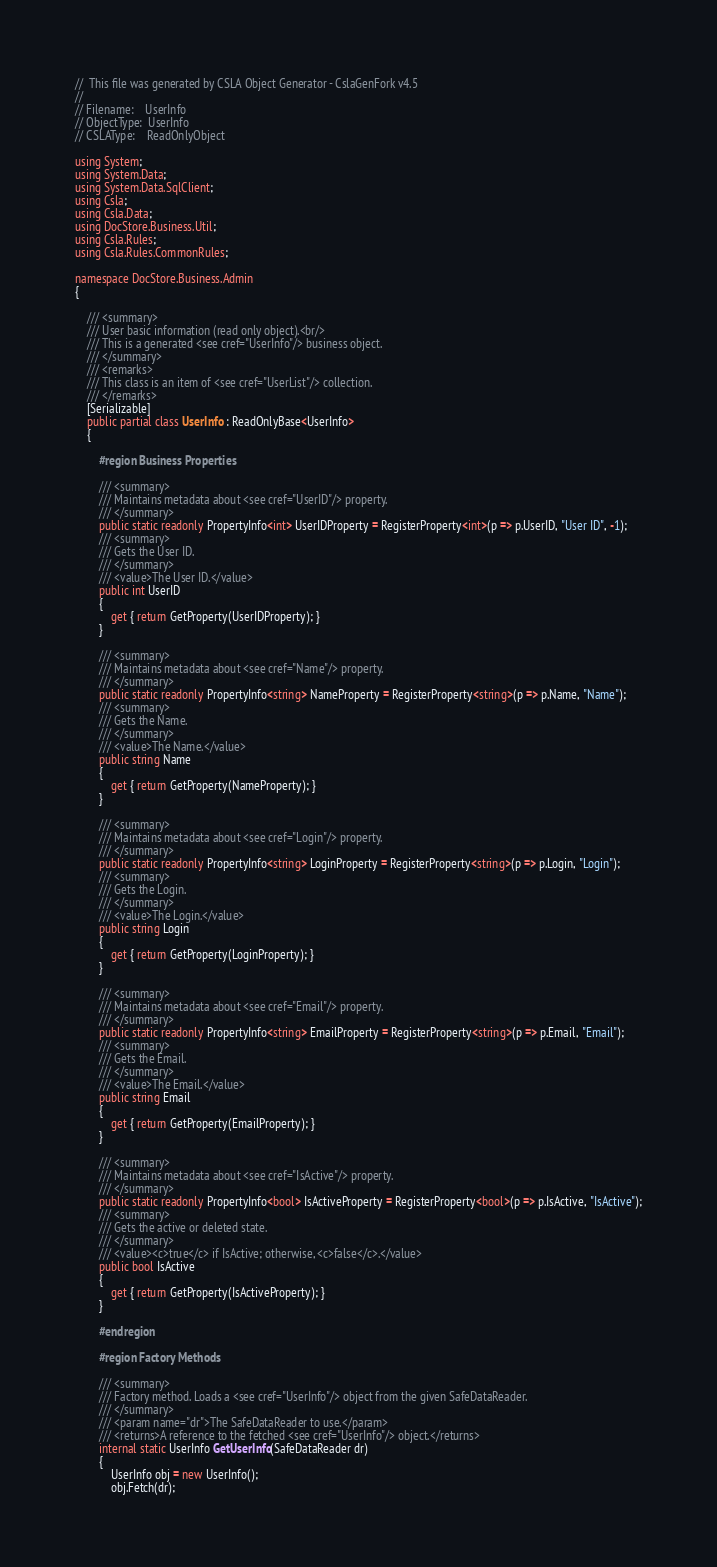Convert code to text. <code><loc_0><loc_0><loc_500><loc_500><_C#_>//  This file was generated by CSLA Object Generator - CslaGenFork v4.5
//
// Filename:    UserInfo
// ObjectType:  UserInfo
// CSLAType:    ReadOnlyObject

using System;
using System.Data;
using System.Data.SqlClient;
using Csla;
using Csla.Data;
using DocStore.Business.Util;
using Csla.Rules;
using Csla.Rules.CommonRules;

namespace DocStore.Business.Admin
{

    /// <summary>
    /// User basic information (read only object).<br/>
    /// This is a generated <see cref="UserInfo"/> business object.
    /// </summary>
    /// <remarks>
    /// This class is an item of <see cref="UserList"/> collection.
    /// </remarks>
    [Serializable]
    public partial class UserInfo : ReadOnlyBase<UserInfo>
    {

        #region Business Properties

        /// <summary>
        /// Maintains metadata about <see cref="UserID"/> property.
        /// </summary>
        public static readonly PropertyInfo<int> UserIDProperty = RegisterProperty<int>(p => p.UserID, "User ID", -1);
        /// <summary>
        /// Gets the User ID.
        /// </summary>
        /// <value>The User ID.</value>
        public int UserID
        {
            get { return GetProperty(UserIDProperty); }
        }

        /// <summary>
        /// Maintains metadata about <see cref="Name"/> property.
        /// </summary>
        public static readonly PropertyInfo<string> NameProperty = RegisterProperty<string>(p => p.Name, "Name");
        /// <summary>
        /// Gets the Name.
        /// </summary>
        /// <value>The Name.</value>
        public string Name
        {
            get { return GetProperty(NameProperty); }
        }

        /// <summary>
        /// Maintains metadata about <see cref="Login"/> property.
        /// </summary>
        public static readonly PropertyInfo<string> LoginProperty = RegisterProperty<string>(p => p.Login, "Login");
        /// <summary>
        /// Gets the Login.
        /// </summary>
        /// <value>The Login.</value>
        public string Login
        {
            get { return GetProperty(LoginProperty); }
        }

        /// <summary>
        /// Maintains metadata about <see cref="Email"/> property.
        /// </summary>
        public static readonly PropertyInfo<string> EmailProperty = RegisterProperty<string>(p => p.Email, "Email");
        /// <summary>
        /// Gets the Email.
        /// </summary>
        /// <value>The Email.</value>
        public string Email
        {
            get { return GetProperty(EmailProperty); }
        }

        /// <summary>
        /// Maintains metadata about <see cref="IsActive"/> property.
        /// </summary>
        public static readonly PropertyInfo<bool> IsActiveProperty = RegisterProperty<bool>(p => p.IsActive, "IsActive");
        /// <summary>
        /// Gets the active or deleted state.
        /// </summary>
        /// <value><c>true</c> if IsActive; otherwise, <c>false</c>.</value>
        public bool IsActive
        {
            get { return GetProperty(IsActiveProperty); }
        }

        #endregion

        #region Factory Methods

        /// <summary>
        /// Factory method. Loads a <see cref="UserInfo"/> object from the given SafeDataReader.
        /// </summary>
        /// <param name="dr">The SafeDataReader to use.</param>
        /// <returns>A reference to the fetched <see cref="UserInfo"/> object.</returns>
        internal static UserInfo GetUserInfo(SafeDataReader dr)
        {
            UserInfo obj = new UserInfo();
            obj.Fetch(dr);</code> 